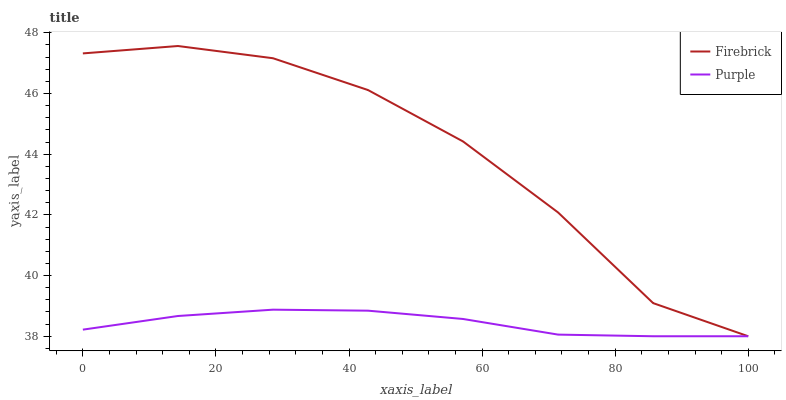Does Purple have the minimum area under the curve?
Answer yes or no. Yes. Does Firebrick have the maximum area under the curve?
Answer yes or no. Yes. Does Firebrick have the minimum area under the curve?
Answer yes or no. No. Is Purple the smoothest?
Answer yes or no. Yes. Is Firebrick the roughest?
Answer yes or no. Yes. Is Firebrick the smoothest?
Answer yes or no. No. Does Purple have the lowest value?
Answer yes or no. Yes. Does Firebrick have the highest value?
Answer yes or no. Yes. Does Purple intersect Firebrick?
Answer yes or no. Yes. Is Purple less than Firebrick?
Answer yes or no. No. Is Purple greater than Firebrick?
Answer yes or no. No. 